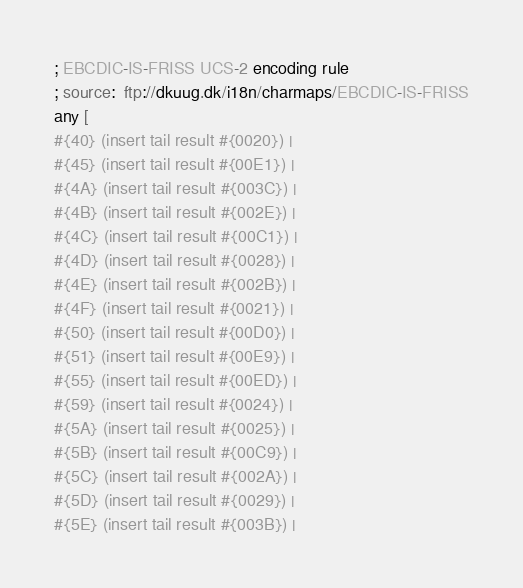Convert code to text. <code><loc_0><loc_0><loc_500><loc_500><_Ruby_>; EBCDIC-IS-FRISS UCS-2 encoding rule
; source:  ftp://dkuug.dk/i18n/charmaps/EBCDIC-IS-FRISS
any [
#{40} (insert tail result #{0020}) | 
#{45} (insert tail result #{00E1}) | 
#{4A} (insert tail result #{003C}) | 
#{4B} (insert tail result #{002E}) | 
#{4C} (insert tail result #{00C1}) | 
#{4D} (insert tail result #{0028}) | 
#{4E} (insert tail result #{002B}) | 
#{4F} (insert tail result #{0021}) | 
#{50} (insert tail result #{00D0}) | 
#{51} (insert tail result #{00E9}) | 
#{55} (insert tail result #{00ED}) | 
#{59} (insert tail result #{0024}) | 
#{5A} (insert tail result #{0025}) | 
#{5B} (insert tail result #{00C9}) | 
#{5C} (insert tail result #{002A}) | 
#{5D} (insert tail result #{0029}) | 
#{5E} (insert tail result #{003B}) | </code> 